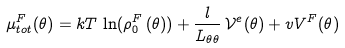Convert formula to latex. <formula><loc_0><loc_0><loc_500><loc_500>\mu ^ { F } _ { t o t } ( \theta ) = k T \, \ln ( \rho _ { 0 } ^ { F } \left ( \theta ) \right ) + \frac { l } { L _ { \theta \theta } } \, \mathcal { V } ^ { e } ( \theta ) + v V ^ { F } ( \theta )</formula> 